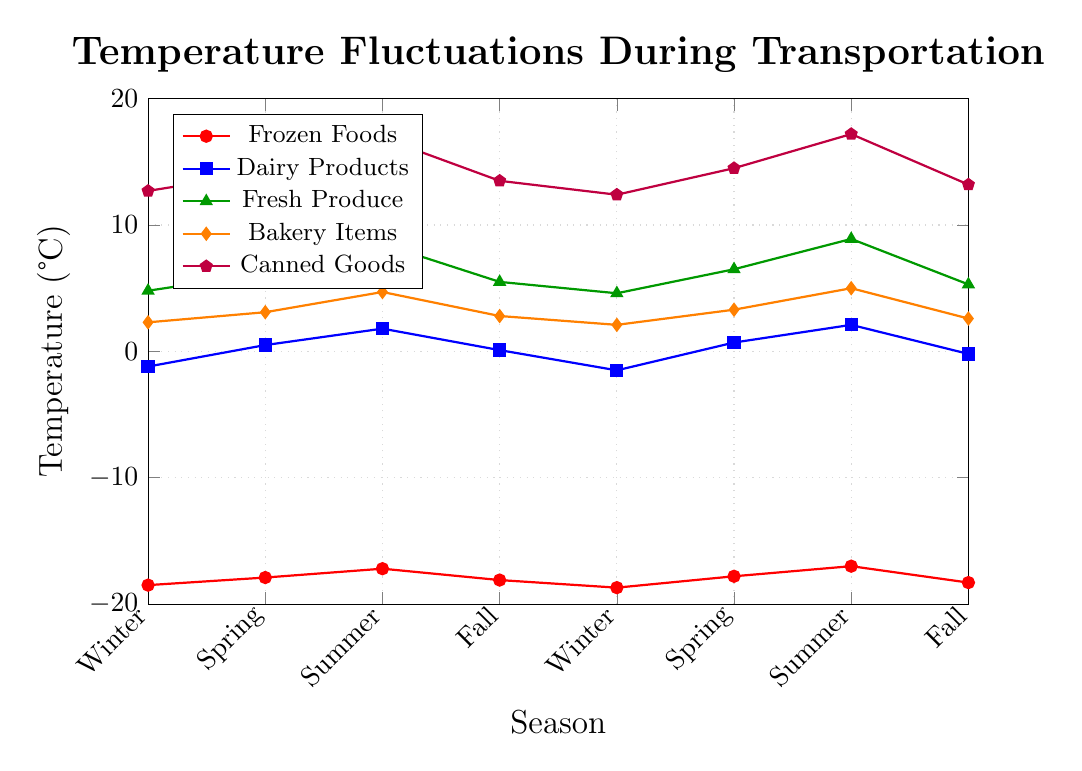Which food category experiences the highest temperature in Summer? The visual chart shows that Canned Goods have the highest temperature during Summer, indicated by the highest point in the chart marked in purple for that season.
Answer: Canned Goods During which season do Bakery Items reach their highest temperature? Inspect the visual chart for the highest point plotted for Bakery Items (orange line) and note the corresponding season.
Answer: Summer What is the overall trend for Frozen Foods across the seasons? The visual chart shows Frozen Foods maintaining consistently low temperatures with slight fluctuations but overall staying below -17°C.
Answer: Consistent with slight fluctuations Compare the temperature for Fresh Produce in Spring and Fall. Which season is warmer? Check the chart for Fresh Produce (green line) and look at the temperatures for Spring and Fall. The temperature in Spring (6.2°C) is higher than in Fall (5.3°C).
Answer: Spring What is the temperature difference for Dairy Products between the highest and lowest points? Identify the highest temperature (Summer at 2.1°C) and the lowest temperature (Winter at -1.5°C) from the Dairy Products line (blue). Calculate the difference: 2.1 - (-1.5) = 3.6°C.
Answer: 3.6°C In which seasons do Canned Goods have temperatures above 15°C? Look at the purple line representing Canned Goods and find the segments above the 15°C mark. These occur in Summer (16.9°C) and Summer again (17.2°C).
Answer: Summer How does the temperature for Fresh Produce change from Winter to Summer? Check the Fresh Produce line (green) from Winter (4.6°C) to Summer (8.5°C) and note the increase in temperature over the seasons.
Answer: Increases What's the average temperature for Bakery Items throughout the seasons? Sum the temperatures of Bakery Items across all seasons (2.3 + 3.1 + 4.7 + 2.8 + 2.1 + 3.3 + 5.0 + 2.6 = 25.9) and divide by the number of data points (8). The average is 25.9 / 8 = 3.24°C.
Answer: 3.24°C Which food category has the smallest temperature variance across seasons? Visually assess each food category's line for consistency in their fluctuations. Frozen Foods (red line) show the least variation, remaining consistently low.
Answer: Frozen Foods 